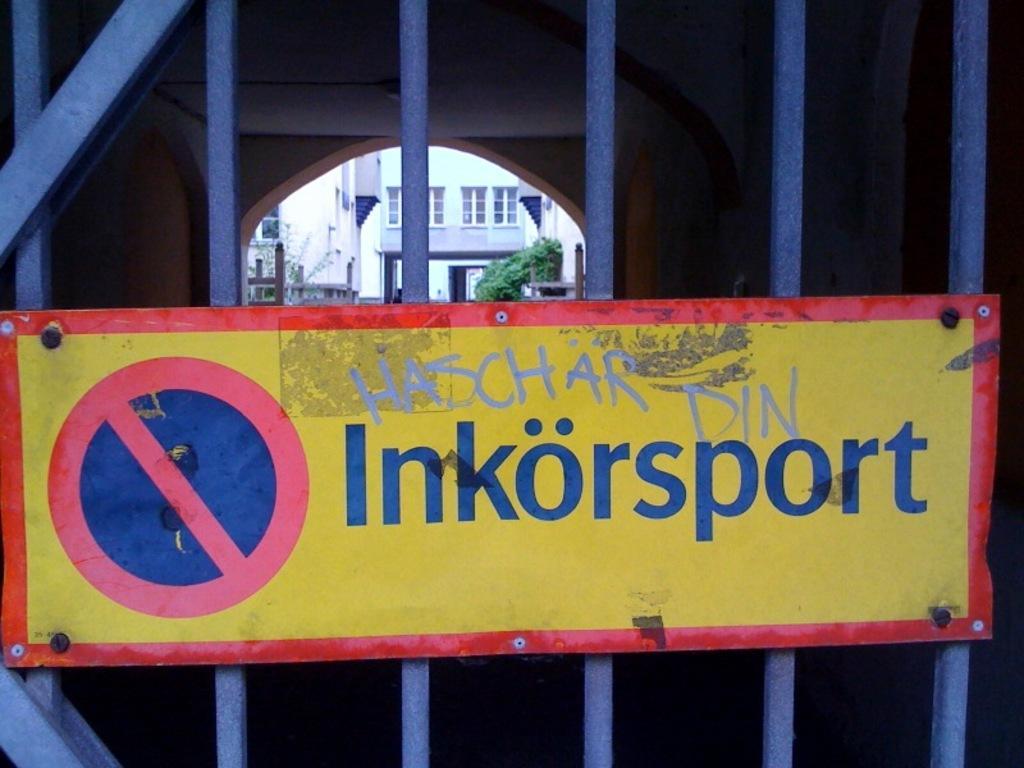Describe this image in one or two sentences. In this picture there is a sign board in the center of the image on a gate and there are buildings and greenery in the background area of the image. 